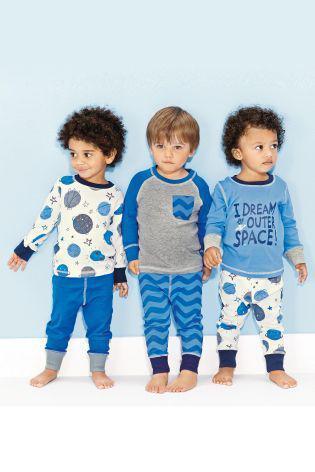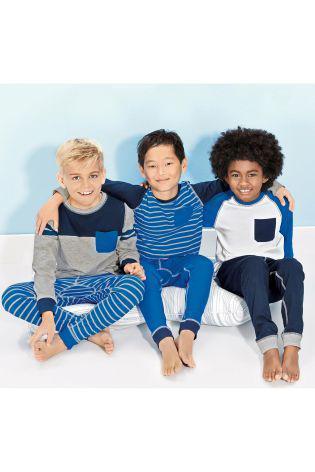The first image is the image on the left, the second image is the image on the right. Assess this claim about the two images: "There is a boy wearing pajamas in the center of each image.". Correct or not? Answer yes or no. Yes. The first image is the image on the left, the second image is the image on the right. For the images displayed, is the sentence "the left image has the middle child sitting criss cross" factually correct? Answer yes or no. No. 